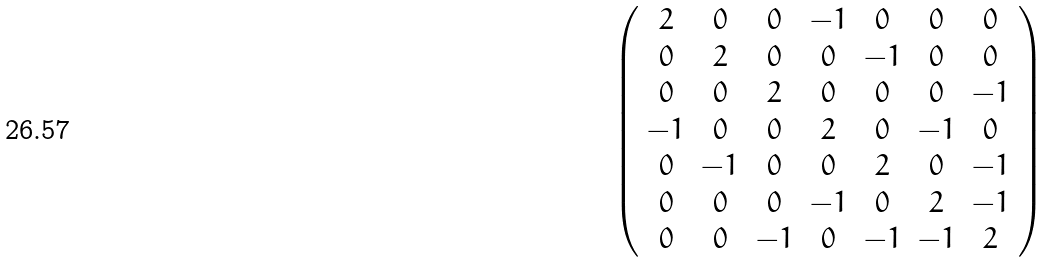<formula> <loc_0><loc_0><loc_500><loc_500>\left ( \begin{array} { c c c c c c c } 2 & 0 & 0 & - 1 & 0 & 0 & 0 \\ 0 & 2 & 0 & 0 & - 1 & 0 & 0 \\ 0 & 0 & 2 & 0 & 0 & 0 & - 1 \\ - 1 & 0 & 0 & 2 & 0 & - 1 & 0 \\ 0 & - 1 & 0 & 0 & 2 & 0 & - 1 \\ 0 & 0 & 0 & - 1 & 0 & 2 & - 1 \\ 0 & 0 & - 1 & 0 & - 1 & - 1 & 2 \end{array} \right )</formula> 